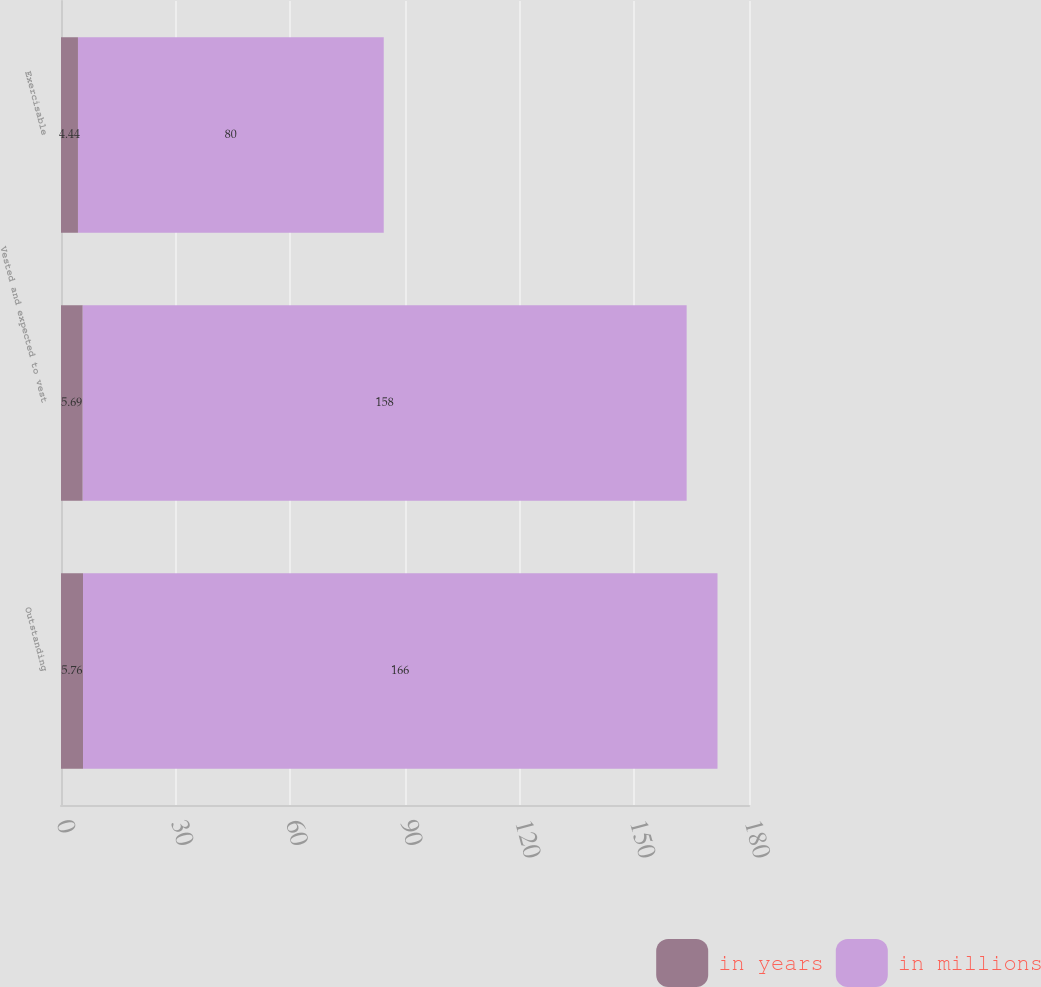Convert chart. <chart><loc_0><loc_0><loc_500><loc_500><stacked_bar_chart><ecel><fcel>Outstanding<fcel>Vested and expected to vest<fcel>Exercisable<nl><fcel>in years<fcel>5.76<fcel>5.69<fcel>4.44<nl><fcel>in millions<fcel>166<fcel>158<fcel>80<nl></chart> 